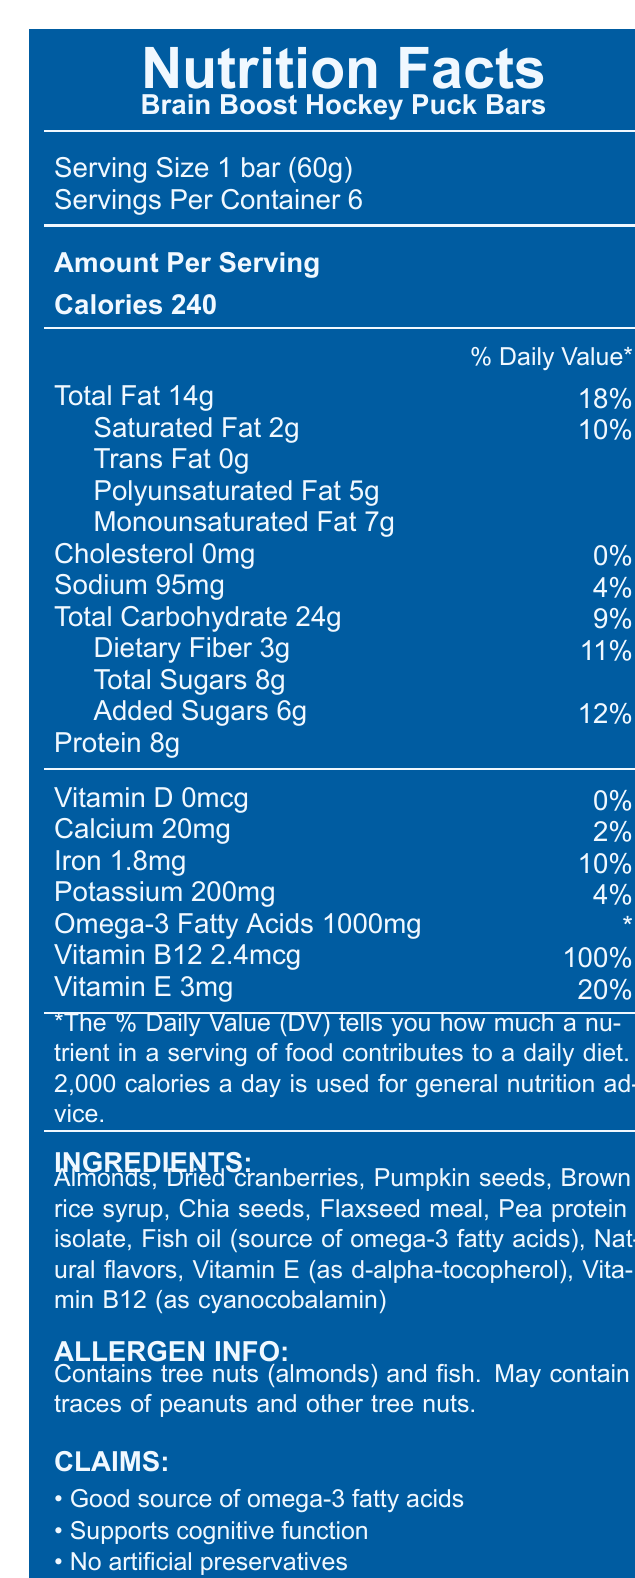what is the serving size of Brain Boost Hockey Puck Bars? The serving size is clearly stated as "1 bar (60g)" under the product name in the document.
Answer: 1 bar (60g) how many servings are in one container? The document mentions "Servings Per Container: 6."
Answer: 6 how many calories are there in one serving of the Brain Boost Hockey Puck Bars? The document lists "Calories 240" under the "Amount Per Serving" section.
Answer: 240 calories what percentage of the daily value of saturated fat does one bar contribute? The document indicates that there are 2g of saturated fat per serving and this constitutes 10% of the daily value.
Answer: 10% how many milligrams of omega-3 fatty acids are in one bar? The document lists "Omega-3 Fatty Acids 1000mg" under its specific section.
Answer: 1000mg which vitamin in the Brain Boost Hockey Puck Bars has the highest daily value percentage? A. Vitamin D B. Calcium C. Vitamin B12 D. Vitamin E The document shows that Vitamin B12 has a daily value percentage of 100%, which is the highest among the listed vitamins.
Answer: C. Vitamin B12 how many grams of total sugars are in one bar? The document lists "Total Sugars 8g" under the carbohydrate section.
Answer: 8g what is the sodium content for one serving of Brain Boost Hockey Puck Bars? A. 95mg B. 200mg C. 5g D. 2g The document lists "Sodium 95mg" under its specific section.
Answer: A. 95mg does the product contain any artificial preservatives? One of the claims listed in the document states "No artificial preservatives."
Answer: No how much protein does one bar contain? The document lists "Protein 8g" under its specific section.
Answer: 8g summarize the main idea of this document. The document includes information on serving size, nutrient content, and health claims, highlighting the snack’s benefits for cognitive function.
Answer: The document provides the nutrition facts, ingredients, allergen information, and claims for "Brain Boost Hockey Puck Bars." It details the serving size, calories, fats, carbohydrates, protein, vitamins, and other nutrients. The snack supports cognitive function and is claimed to be a good source of omega-3 fatty acids, free from artificial preservatives, and non-GMO. what is the main source of omega-3 fatty acids in the Brain Boost Hockey Puck Bars? The ingredient list mentions "Fish oil (source of omega-3 fatty acids)" as one of the ingredients.
Answer: Fish oil are the Brain Boost Hockey Puck Bars non-GMO? One of the claims listed in the document states "Non-GMO."
Answer: Yes can the percentage of daily value for omega-3 fatty acids be determined from this document? The document shows a daily value percentage as "*" indicating it is not specified in the document.
Answer: No how should the product be stored after opening? The document provides the storage instructions stating "Store in a cool, dry place. Consume within 3 days after opening."
Answer: Store in a cool, dry place. Consume within 3 days after opening. does the product contain any allergens? The allergen information section indicates the product "Contains tree nuts (almonds) and fish," and "May contain traces of peanuts and other tree nuts."
Answer: Yes what ingredient used in Brain Boost Hockey Puck Bars is used as a protein source? The ingredient list includes "Pea protein isolate" as one of the ingredients.
Answer: Pea protein isolate 